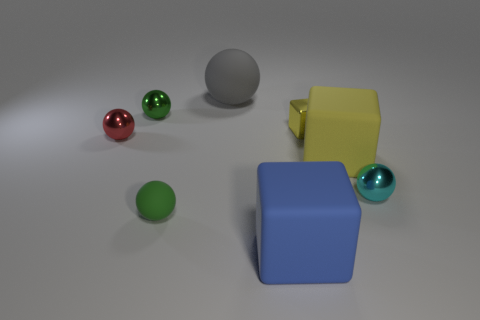There is a cyan object that is the same size as the green metal object; what is its shape?
Your answer should be very brief. Sphere. Is the number of cyan spheres less than the number of balls?
Give a very brief answer. Yes. There is a small thing that is behind the small yellow shiny cube; are there any large gray balls in front of it?
Ensure brevity in your answer.  No. There is a yellow thing that is the same material as the small red thing; what is its shape?
Make the answer very short. Cube. Is there any other thing of the same color as the small matte object?
Provide a succinct answer. Yes. There is a big thing that is the same shape as the small matte thing; what is its material?
Give a very brief answer. Rubber. How many other objects are there of the same size as the blue block?
Give a very brief answer. 2. What size is the metal sphere that is the same color as the tiny rubber ball?
Give a very brief answer. Small. Is the shape of the green thing that is behind the red object the same as  the small yellow thing?
Your answer should be compact. No. How many other objects are there of the same shape as the small red metallic object?
Your answer should be very brief. 4. 